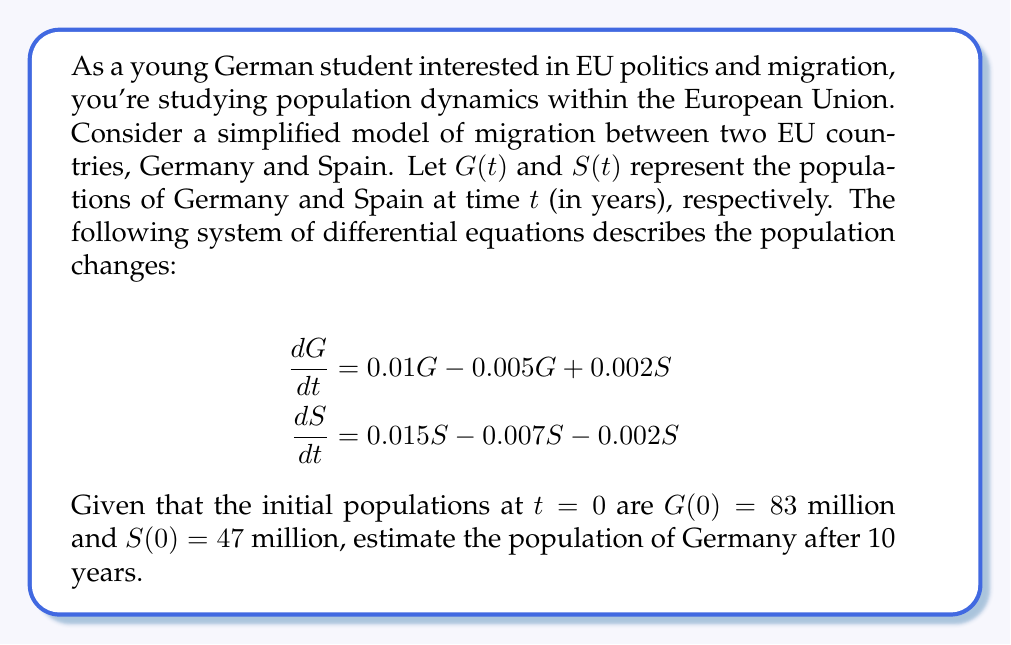Can you answer this question? To solve this problem, we need to follow these steps:

1) First, let's simplify the system of differential equations:

   For Germany: $\frac{dG}{dt} = 0.01G - 0.005G + 0.002S = 0.005G + 0.002S$
   For Spain: $\frac{dS}{dt} = 0.015S - 0.007S - 0.002S = 0.006S$

2) We can see that the equation for Spain doesn't depend on G, so we can solve it independently:

   $\frac{dS}{dt} = 0.006S$

   This is a simple exponential growth equation with solution:
   $S(t) = S(0)e^{0.006t} = 47e^{0.006t}$

3) Now we can substitute this into the equation for Germany:

   $\frac{dG}{dt} = 0.005G + 0.002(47e^{0.006t})$

4) This is a linear first-order differential equation. The general solution is:

   $G(t) = ce^{0.005t} + \frac{0.002 \cdot 47e^{0.006t}}{0.006 - 0.005} = ce^{0.005t} + 94e^{0.006t}$

   where $c$ is a constant we need to determine from the initial condition.

5) Using $G(0) = 83$, we can find $c$:

   $83 = c + 94$
   $c = -11$

6) Therefore, the complete solution for Germany's population is:

   $G(t) = -11e^{0.005t} + 94e^{0.006t}$

7) To find the population after 10 years, we substitute $t = 10$:

   $G(10) = -11e^{0.05} + 94e^{0.06}$

8) Calculating this:

   $G(10) \approx -11.57 + 100.12 = 88.55$ million

Therefore, the estimated population of Germany after 10 years is approximately 88.55 million.
Answer: 88.55 million 